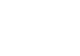Convert code to text. <code><loc_0><loc_0><loc_500><loc_500><_Bash_>
</code> 